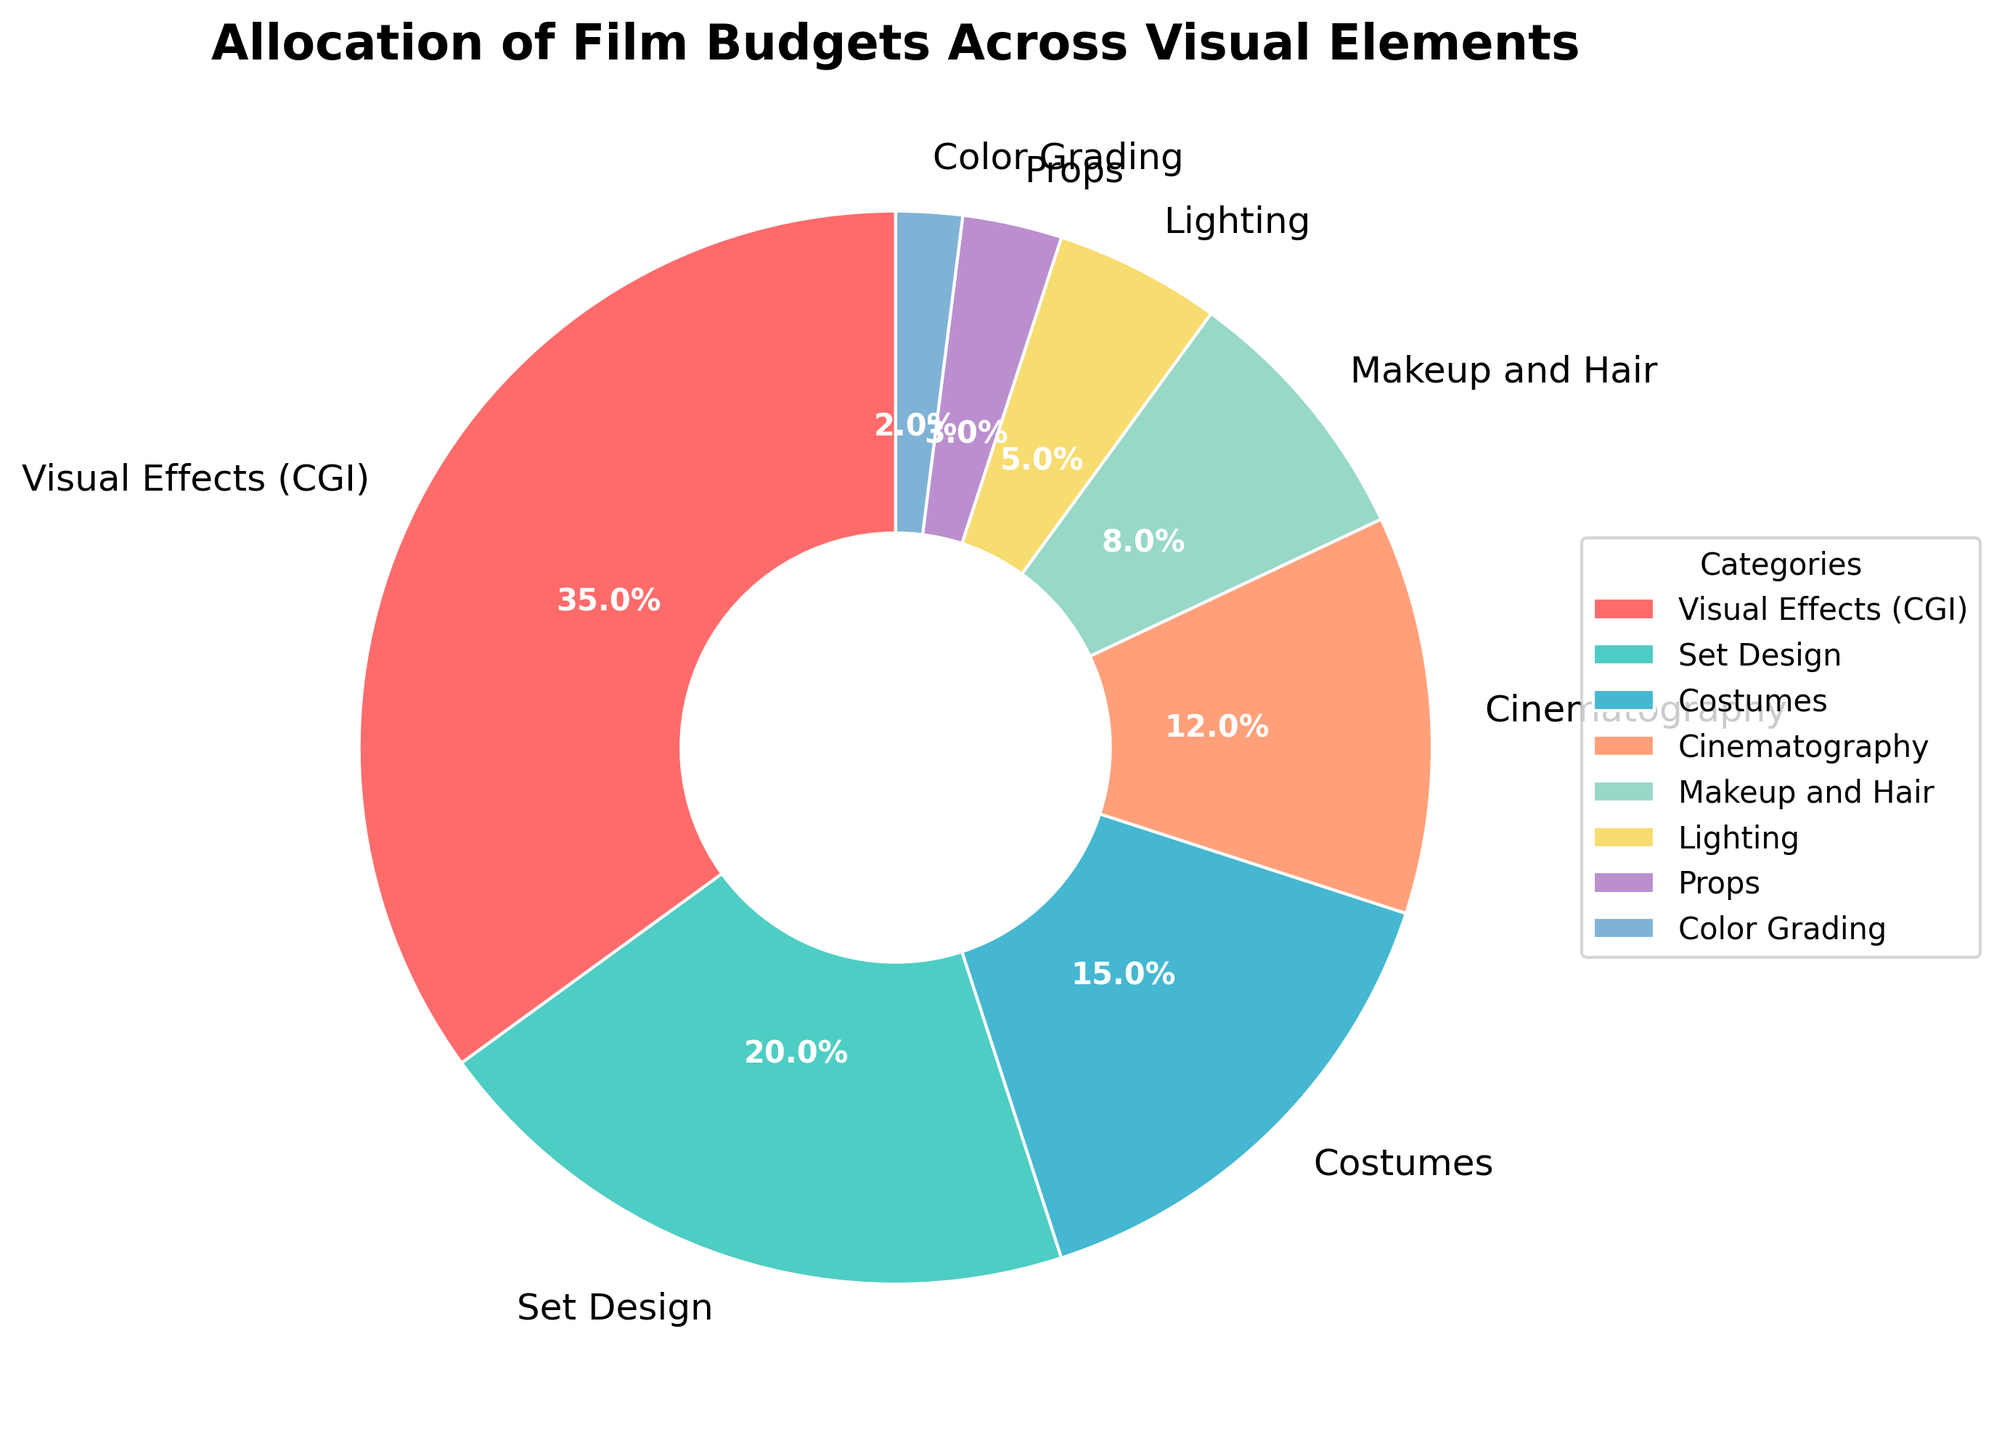What's the largest category in the pie chart? The largest category is identified by finding the wedge occupying the most space in the pie chart. Visual Effects (CGI) has the largest wedge, showing 35%.
Answer: Visual Effects (CGI) How much percentage is allocated to Costumes and Props combined? To find the combined percentage, add the percentage of Costumes (15%) and Props (3%). 15% + 3% = 18%.
Answer: 18% Which category has a larger budget allocation: Lighting or Makeup and Hair? Compare the percentage of Lighting (5%) with Makeup and Hair (8%). Makeup and Hair has a larger allocation.
Answer: Makeup and Hair Which element has the smallest budget allocation? Identify the category with the smallest wedge in the pie chart. Color Grading with 2% is the smallest category.
Answer: Color Grading What is the combined budget allocation for Set Design and Cinematography? Add the percentages of Set Design (20%) and Cinematography (12%). 20% + 12% = 32%.
Answer: 32% How does the budget for Visual Effects (CGI) compare with the total budget for Cinematography, Lighting, and Props? Add the percentages of Cinematography (12%), Lighting (5%), and Props (3%). Then compare the sum (12% + 5% + 3% = 20%) with Visual Effects (CGI) which is 35%. 35% is greater than 20%.
Answer: Visual Effects (CGI) is greater Which category is denoted by a purple wedge, and what is its percentage? Identify the wedge colored purple in the pie chart. Purple represents Props and it occupies 3% of the pie.
Answer: Props, 3% What percentage of the budget is dedicated to elements other than Visual Effects (CGI) and Set Design? Subtract the sum of the percentages for Visual Effects (CGI) (35%) and Set Design (20%) from 100%. 100% - (35% + 20%) = 45%.
Answer: 45% What is the difference in percentage points between the budget for Lighting and Costumes? Subtract the percentage allocated to Lighting (5%) from that allocated to Costumes (15%). 15% - 5% = 10%.
Answer: 10% 